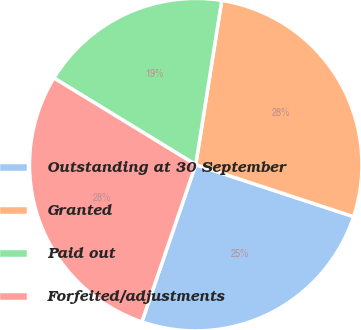Convert chart to OTSL. <chart><loc_0><loc_0><loc_500><loc_500><pie_chart><fcel>Outstanding at 30 September<fcel>Granted<fcel>Paid out<fcel>Forfeited/adjustments<nl><fcel>25.19%<fcel>27.57%<fcel>18.77%<fcel>28.47%<nl></chart> 